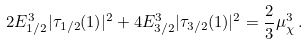<formula> <loc_0><loc_0><loc_500><loc_500>2 E _ { 1 / 2 } ^ { 3 } | \tau _ { 1 / 2 } ( 1 ) | ^ { 2 } + 4 E _ { 3 / 2 } ^ { 3 } | \tau _ { 3 / 2 } ( 1 ) | ^ { 2 } = \frac { 2 } { 3 } \mu _ { \chi } ^ { 3 } \, .</formula> 